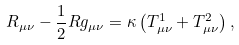<formula> <loc_0><loc_0><loc_500><loc_500>R _ { \mu \nu } - \frac { 1 } { 2 } R g _ { \mu \nu } = \kappa \left ( T ^ { 1 } _ { \mu \nu } + T ^ { 2 } _ { \mu \nu } \right ) ,</formula> 